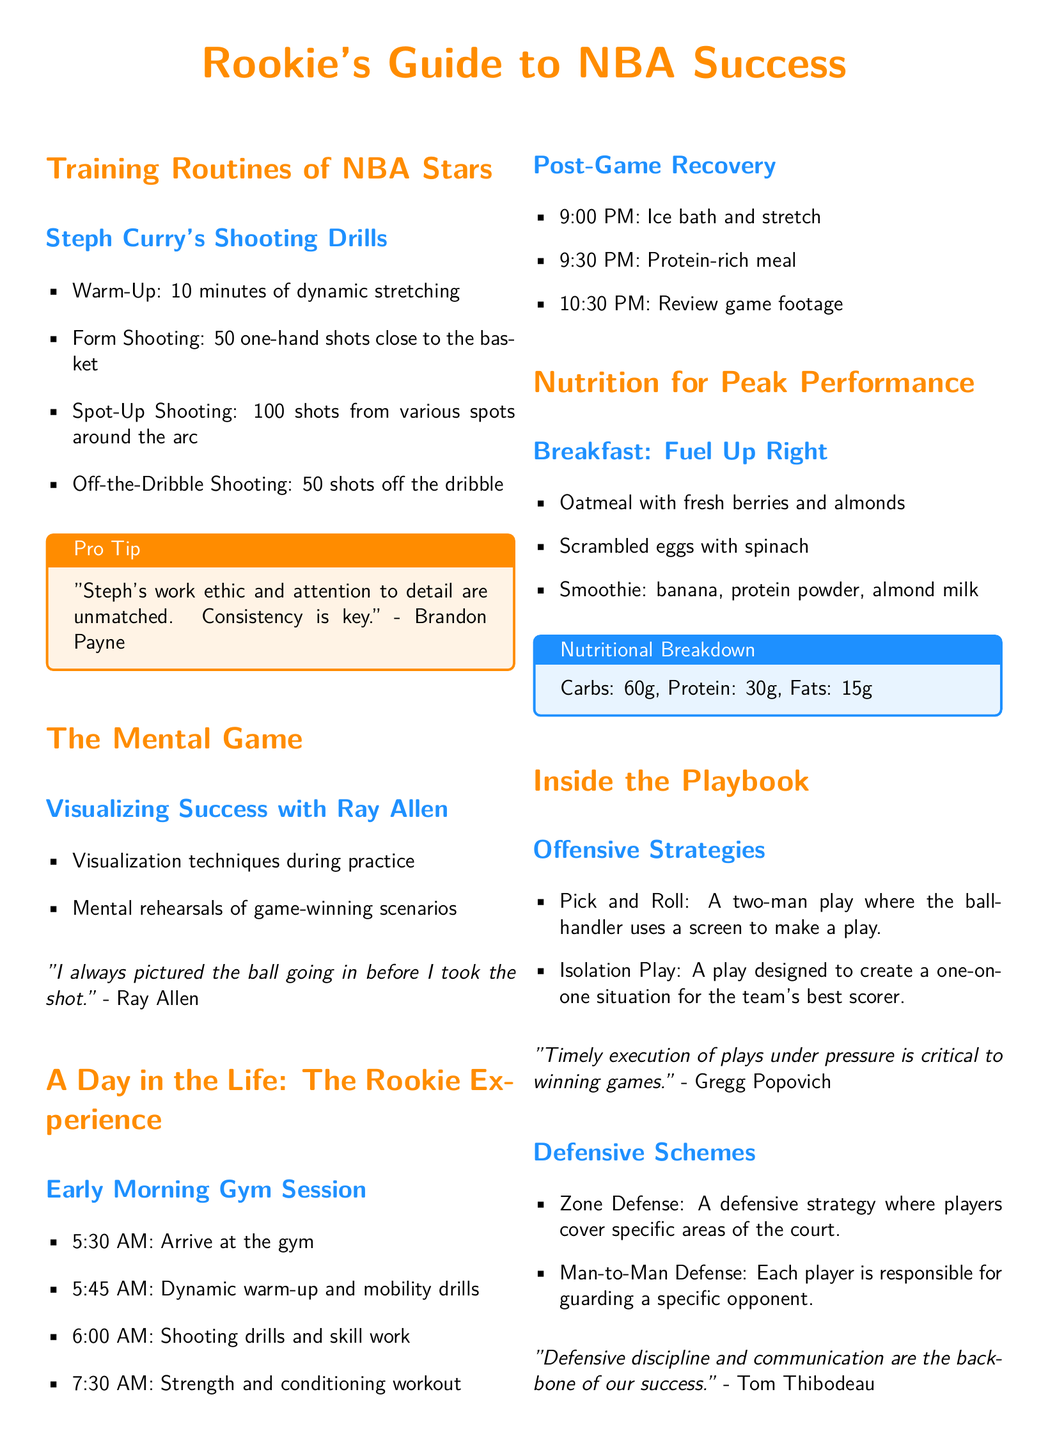What is the duration of Steph Curry's warm-up? The document states that Steph Curry's warm-up lasts for 10 minutes.
Answer: 10 minutes How many shots does Steph Curry take from various spots around the arc? The document mentions that Curry takes 100 shots from different spots around the arc during his routine.
Answer: 100 shots What is the first meal listed in the nutrition section? The document lists oatmeal with fresh berries and almonds as the first breakfast item.
Answer: Oatmeal with fresh berries and almonds At what time does the early morning gym session start for the rookie? The document indicates that the early morning gym session starts at 5:30 AM.
Answer: 5:30 AM Which defensive strategy requires players to cover specific areas of the court? The document clearly states that Zone Defense is a strategy where players cover specific areas of the court.
Answer: Zone Defense What quote is attributed to Ray Allen regarding visualization? The document quotes Ray Allen saying, "I always pictured the ball going in before I took the shot."
Answer: "I always pictured the ball going in before I took the shot." How many grams of protein are noted in the nutritional breakdown? The nutritional breakdown in the document specifies that there are 30 grams of protein.
Answer: 30g What are the two types of offensive strategies mentioned? The document mentions both Pick and Roll and Isolation Play as offensive strategies.
Answer: Pick and Roll, Isolation Play Who provided the quote on timely execution of plays under pressure? The quote about timely execution is attributed to Gregg Popovich in the document.
Answer: Gregg Popovich 